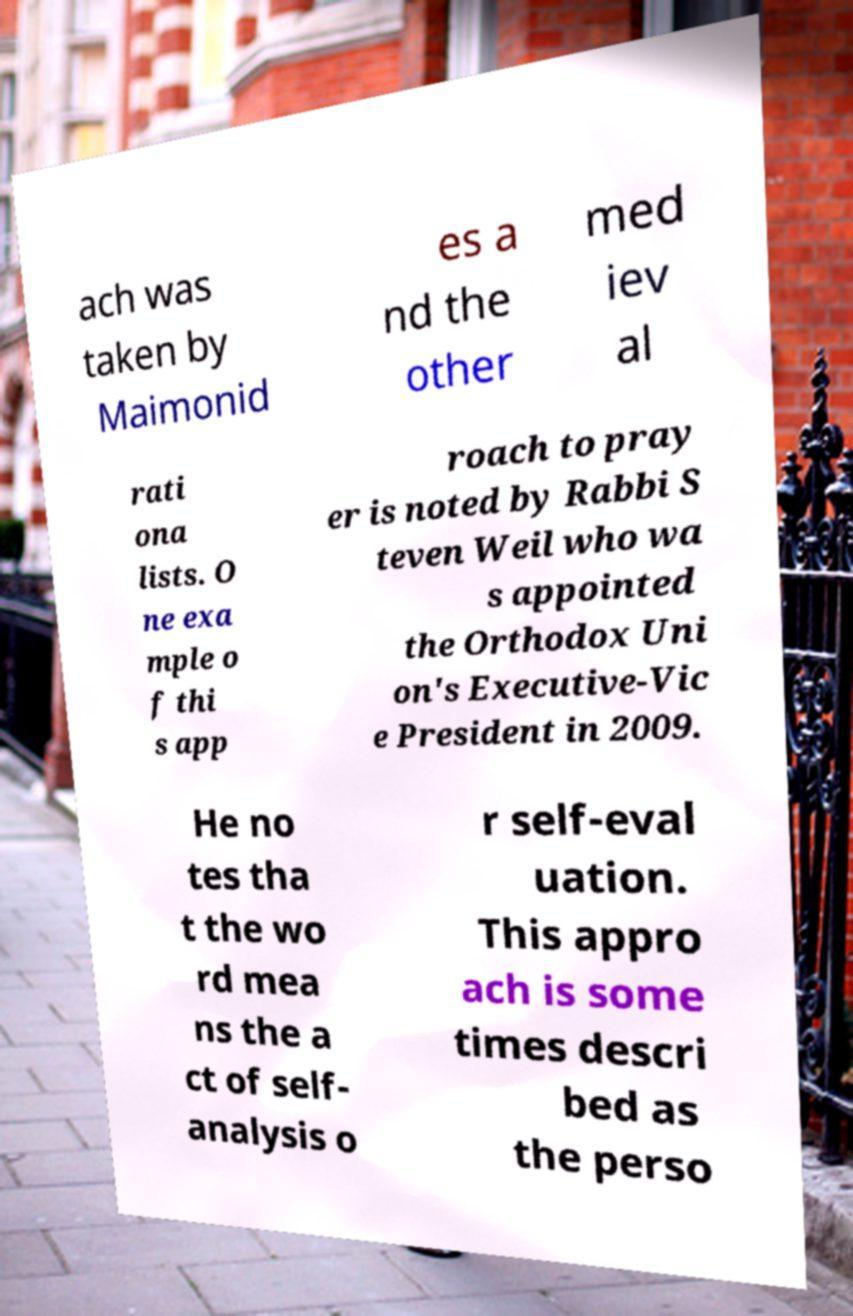For documentation purposes, I need the text within this image transcribed. Could you provide that? ach was taken by Maimonid es a nd the other med iev al rati ona lists. O ne exa mple o f thi s app roach to pray er is noted by Rabbi S teven Weil who wa s appointed the Orthodox Uni on's Executive-Vic e President in 2009. He no tes tha t the wo rd mea ns the a ct of self- analysis o r self-eval uation. This appro ach is some times descri bed as the perso 